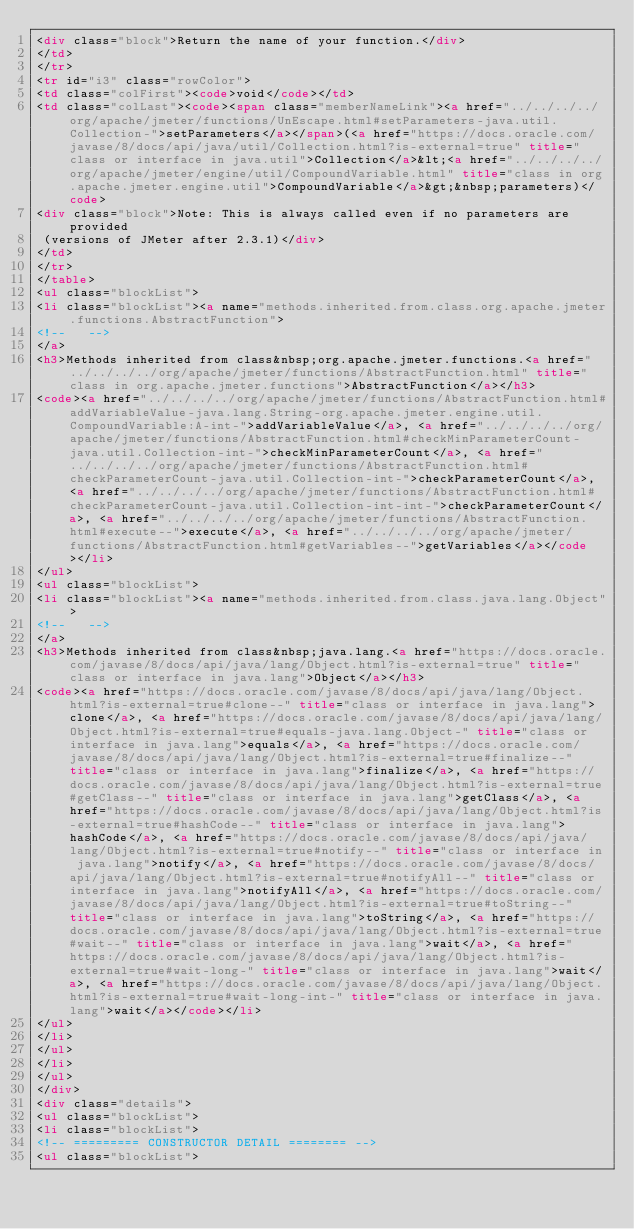<code> <loc_0><loc_0><loc_500><loc_500><_HTML_><div class="block">Return the name of your function.</div>
</td>
</tr>
<tr id="i3" class="rowColor">
<td class="colFirst"><code>void</code></td>
<td class="colLast"><code><span class="memberNameLink"><a href="../../../../org/apache/jmeter/functions/UnEscape.html#setParameters-java.util.Collection-">setParameters</a></span>(<a href="https://docs.oracle.com/javase/8/docs/api/java/util/Collection.html?is-external=true" title="class or interface in java.util">Collection</a>&lt;<a href="../../../../org/apache/jmeter/engine/util/CompoundVariable.html" title="class in org.apache.jmeter.engine.util">CompoundVariable</a>&gt;&nbsp;parameters)</code>
<div class="block">Note: This is always called even if no parameters are provided
 (versions of JMeter after 2.3.1)</div>
</td>
</tr>
</table>
<ul class="blockList">
<li class="blockList"><a name="methods.inherited.from.class.org.apache.jmeter.functions.AbstractFunction">
<!--   -->
</a>
<h3>Methods inherited from class&nbsp;org.apache.jmeter.functions.<a href="../../../../org/apache/jmeter/functions/AbstractFunction.html" title="class in org.apache.jmeter.functions">AbstractFunction</a></h3>
<code><a href="../../../../org/apache/jmeter/functions/AbstractFunction.html#addVariableValue-java.lang.String-org.apache.jmeter.engine.util.CompoundVariable:A-int-">addVariableValue</a>, <a href="../../../../org/apache/jmeter/functions/AbstractFunction.html#checkMinParameterCount-java.util.Collection-int-">checkMinParameterCount</a>, <a href="../../../../org/apache/jmeter/functions/AbstractFunction.html#checkParameterCount-java.util.Collection-int-">checkParameterCount</a>, <a href="../../../../org/apache/jmeter/functions/AbstractFunction.html#checkParameterCount-java.util.Collection-int-int-">checkParameterCount</a>, <a href="../../../../org/apache/jmeter/functions/AbstractFunction.html#execute--">execute</a>, <a href="../../../../org/apache/jmeter/functions/AbstractFunction.html#getVariables--">getVariables</a></code></li>
</ul>
<ul class="blockList">
<li class="blockList"><a name="methods.inherited.from.class.java.lang.Object">
<!--   -->
</a>
<h3>Methods inherited from class&nbsp;java.lang.<a href="https://docs.oracle.com/javase/8/docs/api/java/lang/Object.html?is-external=true" title="class or interface in java.lang">Object</a></h3>
<code><a href="https://docs.oracle.com/javase/8/docs/api/java/lang/Object.html?is-external=true#clone--" title="class or interface in java.lang">clone</a>, <a href="https://docs.oracle.com/javase/8/docs/api/java/lang/Object.html?is-external=true#equals-java.lang.Object-" title="class or interface in java.lang">equals</a>, <a href="https://docs.oracle.com/javase/8/docs/api/java/lang/Object.html?is-external=true#finalize--" title="class or interface in java.lang">finalize</a>, <a href="https://docs.oracle.com/javase/8/docs/api/java/lang/Object.html?is-external=true#getClass--" title="class or interface in java.lang">getClass</a>, <a href="https://docs.oracle.com/javase/8/docs/api/java/lang/Object.html?is-external=true#hashCode--" title="class or interface in java.lang">hashCode</a>, <a href="https://docs.oracle.com/javase/8/docs/api/java/lang/Object.html?is-external=true#notify--" title="class or interface in java.lang">notify</a>, <a href="https://docs.oracle.com/javase/8/docs/api/java/lang/Object.html?is-external=true#notifyAll--" title="class or interface in java.lang">notifyAll</a>, <a href="https://docs.oracle.com/javase/8/docs/api/java/lang/Object.html?is-external=true#toString--" title="class or interface in java.lang">toString</a>, <a href="https://docs.oracle.com/javase/8/docs/api/java/lang/Object.html?is-external=true#wait--" title="class or interface in java.lang">wait</a>, <a href="https://docs.oracle.com/javase/8/docs/api/java/lang/Object.html?is-external=true#wait-long-" title="class or interface in java.lang">wait</a>, <a href="https://docs.oracle.com/javase/8/docs/api/java/lang/Object.html?is-external=true#wait-long-int-" title="class or interface in java.lang">wait</a></code></li>
</ul>
</li>
</ul>
</li>
</ul>
</div>
<div class="details">
<ul class="blockList">
<li class="blockList">
<!-- ========= CONSTRUCTOR DETAIL ======== -->
<ul class="blockList"></code> 